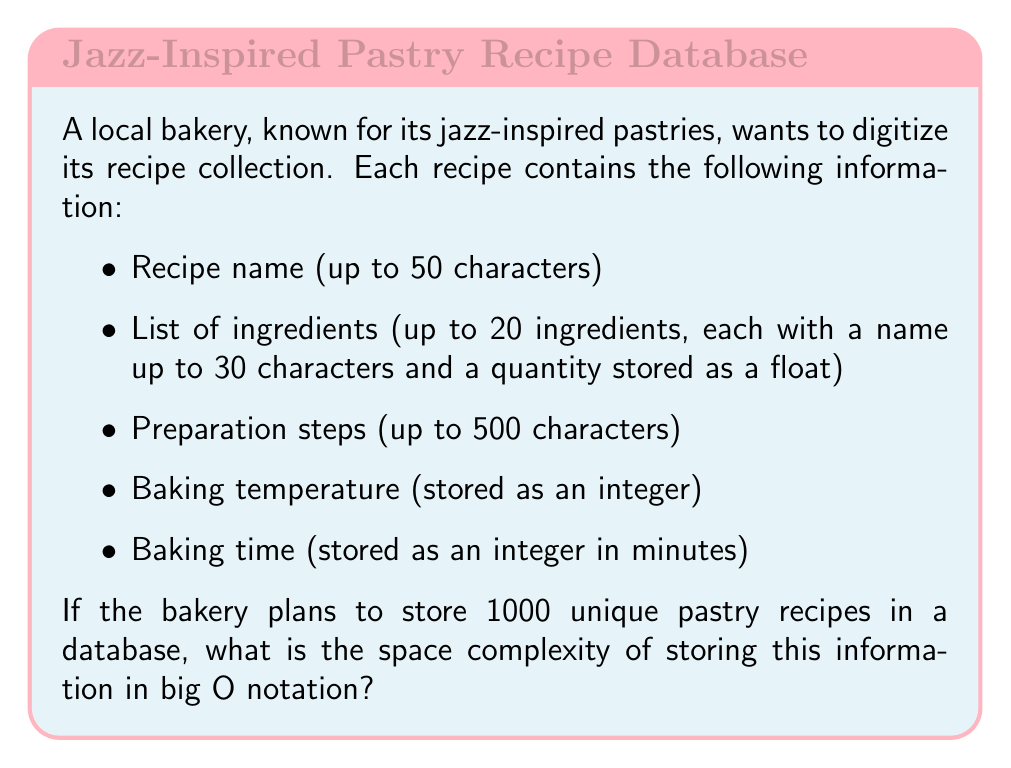Provide a solution to this math problem. To calculate the space complexity, we need to determine the maximum amount of space required for each recipe and then multiply it by the number of recipes. Let's break it down step by step:

1. Recipe name: 
   - Up to 50 characters = 50 bytes

2. List of ingredients:
   - For each ingredient:
     - Name: up to 30 characters = 30 bytes
     - Quantity: 1 float = 4 bytes
   - Total per ingredient: 34 bytes
   - Maximum 20 ingredients: 20 * 34 = 680 bytes

3. Preparation steps:
   - Up to 500 characters = 500 bytes

4. Baking temperature:
   - 1 integer = 4 bytes

5. Baking time:
   - 1 integer = 4 bytes

Total space per recipe:
$$ 50 + 680 + 500 + 4 + 4 = 1238 \text{ bytes} $$

For 1000 recipes:
$$ 1238 * 1000 = 1,238,000 \text{ bytes} $$

In big O notation, we express this as $O(n)$, where $n$ is the number of recipes. This is because the space required grows linearly with the number of recipes stored.

The constant factors and lower-order terms are dropped in big O notation, so even though we calculated the exact number of bytes, we express the space complexity simply as $O(n)$.
Answer: $O(n)$, where $n$ is the number of recipes stored in the database. 